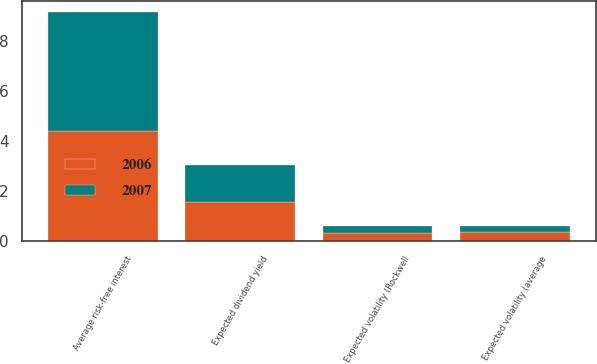Convert chart to OTSL. <chart><loc_0><loc_0><loc_500><loc_500><stacked_bar_chart><ecel><fcel>Average risk-free interest<fcel>Expected dividend yield<fcel>Expected volatility (Rockwell<fcel>Expected volatility (average<nl><fcel>2007<fcel>4.72<fcel>1.49<fcel>0.28<fcel>0.25<nl><fcel>2006<fcel>4.41<fcel>1.56<fcel>0.32<fcel>0.36<nl></chart> 